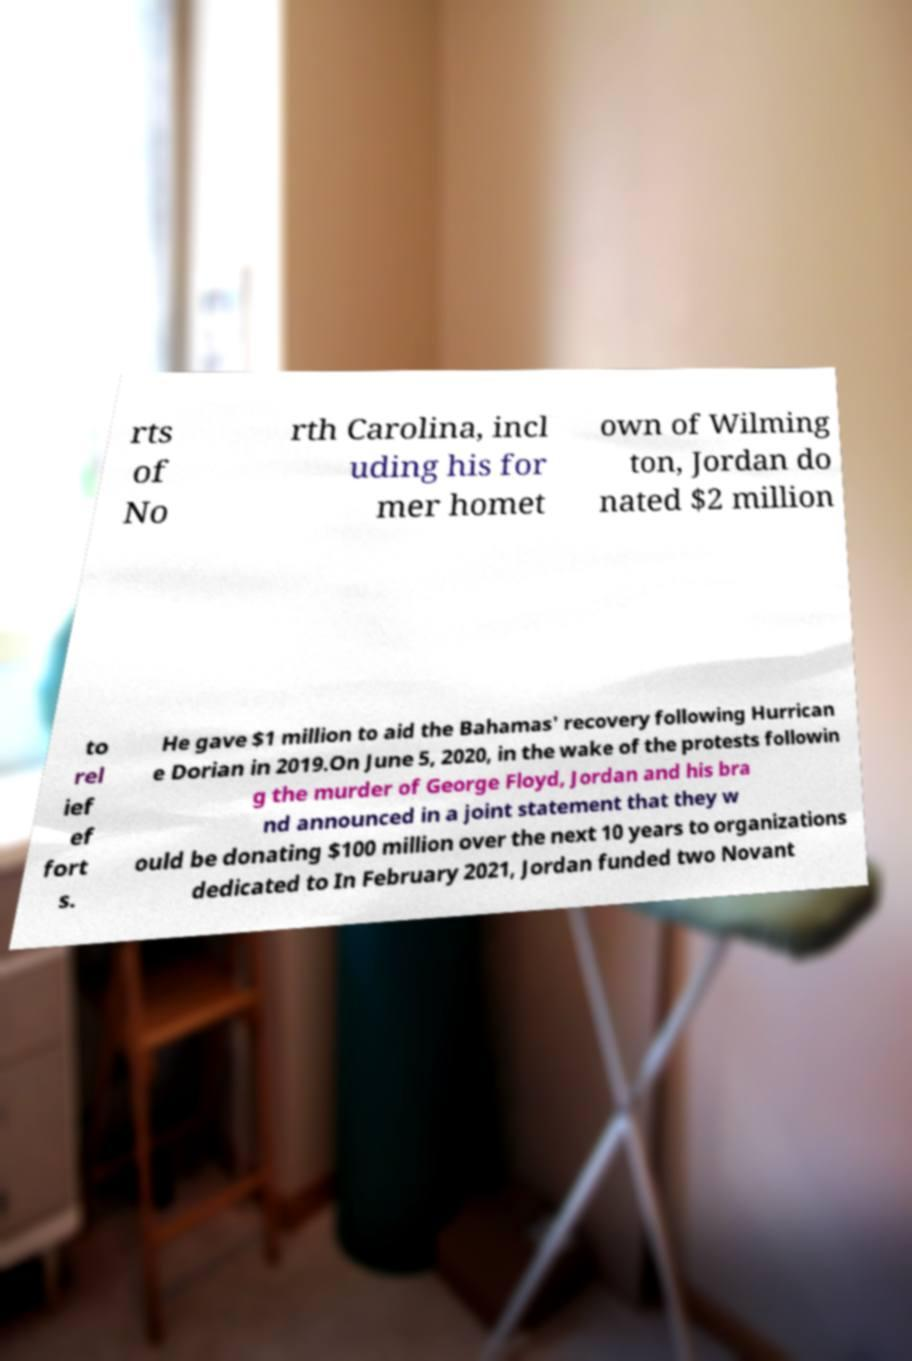There's text embedded in this image that I need extracted. Can you transcribe it verbatim? rts of No rth Carolina, incl uding his for mer homet own of Wilming ton, Jordan do nated $2 million to rel ief ef fort s. He gave $1 million to aid the Bahamas' recovery following Hurrican e Dorian in 2019.On June 5, 2020, in the wake of the protests followin g the murder of George Floyd, Jordan and his bra nd announced in a joint statement that they w ould be donating $100 million over the next 10 years to organizations dedicated to In February 2021, Jordan funded two Novant 